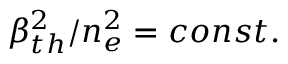Convert formula to latex. <formula><loc_0><loc_0><loc_500><loc_500>\beta _ { t h } ^ { 2 } / n _ { e } ^ { 2 } = c o n s t .</formula> 